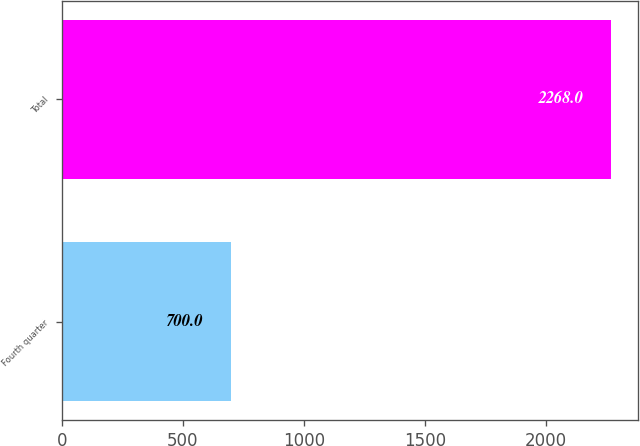Convert chart to OTSL. <chart><loc_0><loc_0><loc_500><loc_500><bar_chart><fcel>Fourth quarter<fcel>Total<nl><fcel>700<fcel>2268<nl></chart> 